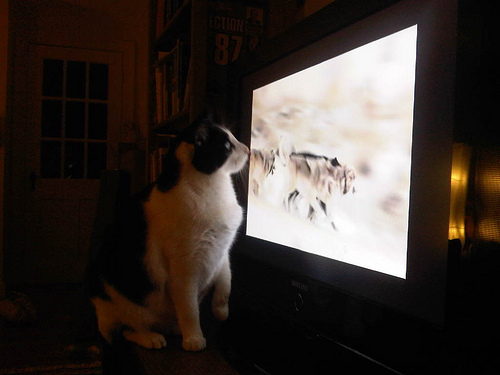<image>What is next to the window? There is no window in the image. However, it can be a cat or a picture or a door. What is next to the window? I don't know what is next to the window. It can be seen 'cat', 'picture' or 'door'. 